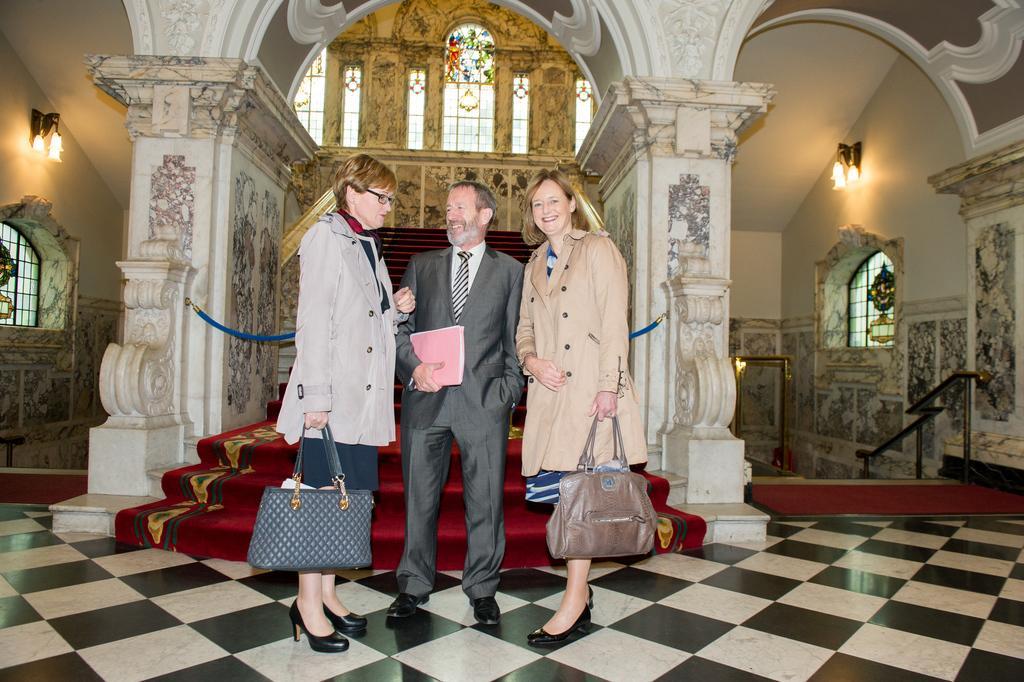How would you summarize this image in a sentence or two? This is an inside view picture of a building. We can see the lights, objects, glass windows, stairs, rope. We can see the carpet on the stairs. We can see the women are holding handbags. We can see a man is holding a book and he is smiling. They all are standing. At the bottom portion of the picture we can see the floor. On the left side of the picture we can see a railing. 